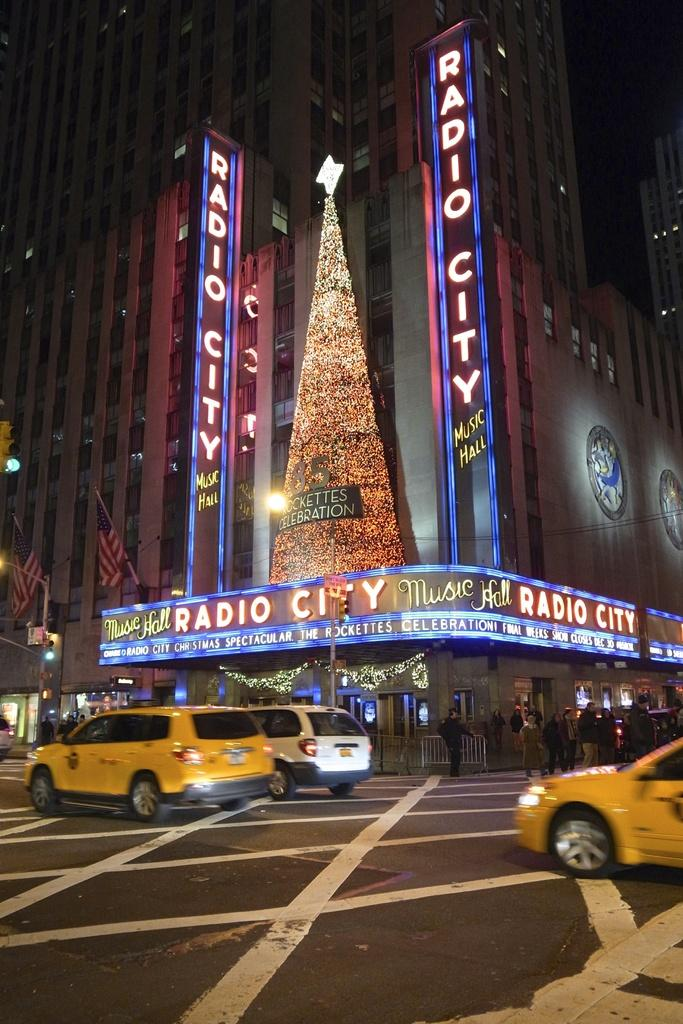What is the lighting condition in the image? The image was taken in the dark. What can be seen on the road in the image? There are cars on the road in the image. What is visible in the background of the image? There is a building and boards with text in the background of the image. How many sources of light can be seen in the image? There are many lights visible in the image. What type of tooth is visible in the image? There is no tooth present in the image. Can you describe the cave in the background of the image? There is no cave present in the image; it features a building and boards with text in the background. 